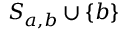Convert formula to latex. <formula><loc_0><loc_0><loc_500><loc_500>S _ { a , b } \cup \{ b \}</formula> 